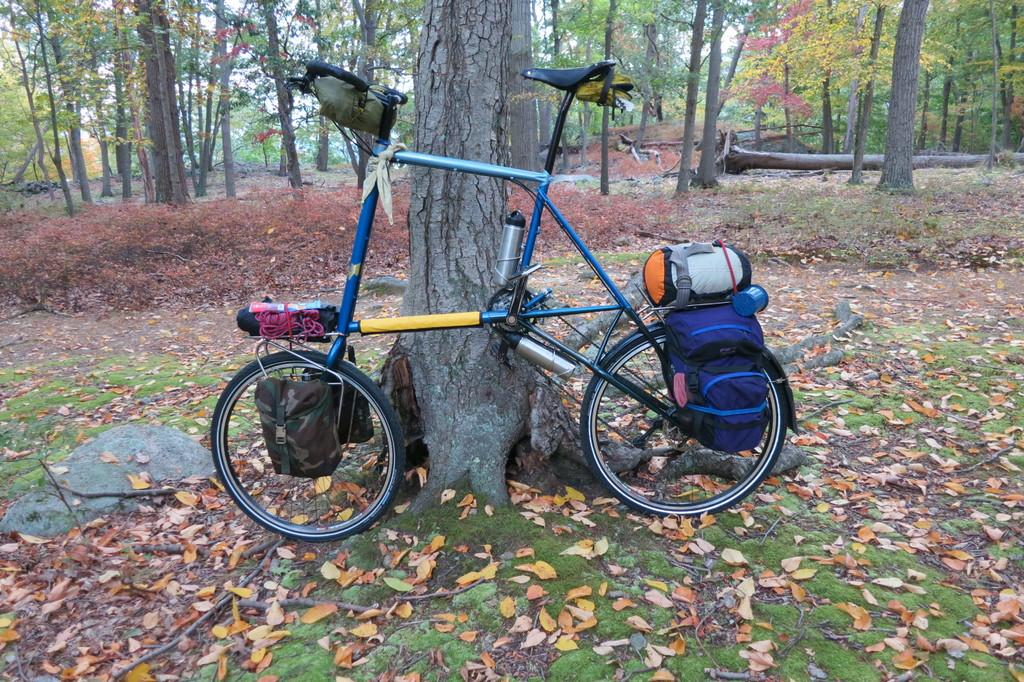What is the main object in the image? There is a bicycle in the image. What else can be seen in the image besides the bicycle? There are bottles and baggage visible in the image. What can be seen in the background of the image? There are trees in the background of the image. How many women are swinging on the bicycle in the image? There are no women or swings present in the image. 